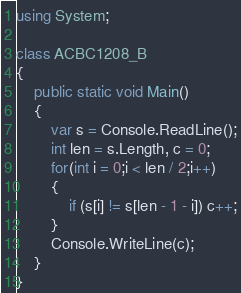<code> <loc_0><loc_0><loc_500><loc_500><_C#_>using System;

class ACBC1208_B
{
    public static void Main()
    {
        var s = Console.ReadLine();
        int len = s.Length, c = 0;
        for(int i = 0;i < len / 2;i++)
        {
            if (s[i] != s[len - 1 - i]) c++;
        }
        Console.WriteLine(c);
    }
}
</code> 